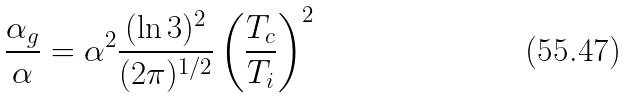Convert formula to latex. <formula><loc_0><loc_0><loc_500><loc_500>\frac { \alpha _ { g } } { \alpha } = \alpha ^ { 2 } \frac { ( \ln 3 ) ^ { 2 } } { ( 2 \pi ) ^ { 1 / 2 } } \left ( \frac { T _ { c } } { T _ { i } } \right ) ^ { 2 }</formula> 